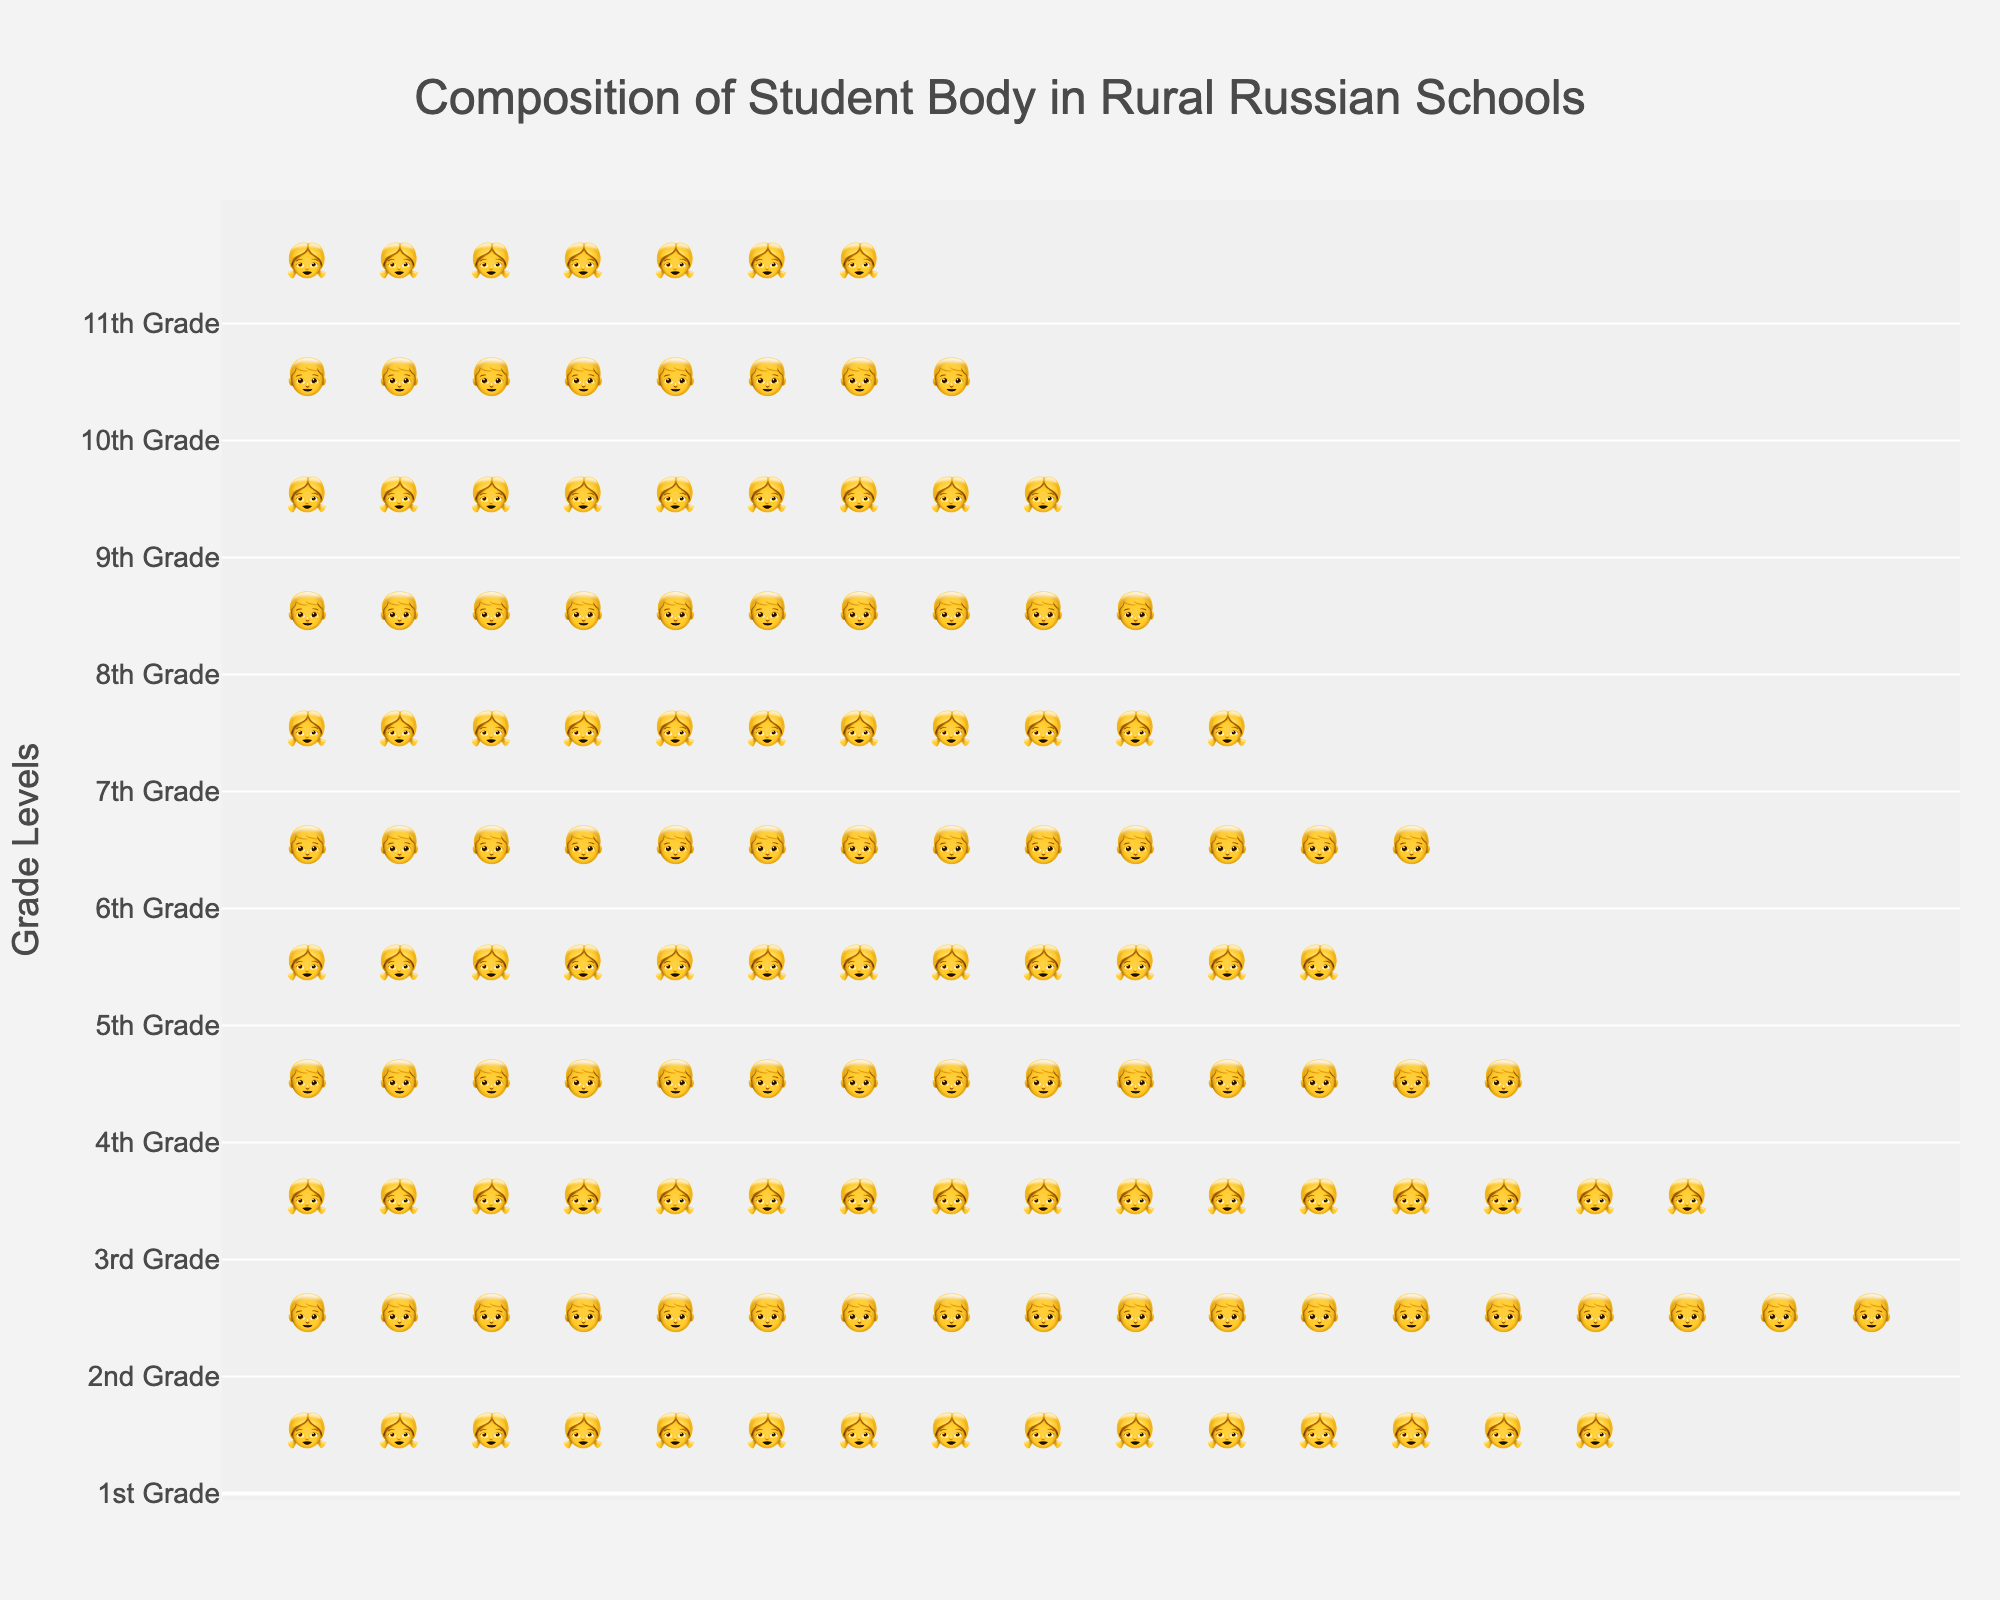what is the title of the figure? The title is usually placed at the top of the figure. It provides a brief description of what the figure illustrates. Here, it is written in a large font to be easily visible.
Answer: Composition of Student Body in Rural Russian Schools How many students are in 2nd grade? The figure uses icons to represent students. There are 18 icons for the 2nd grade, indicating the number of students.
Answer: 18 Which grade has the least number of students? By comparing the number of icons for each grade, 11th grade has the fewest, with only 7 icons.
Answer: 11th Grade What is the difference in the number of students between 1st and 11th grades? Grade 1 has 15 students, and grade 11 has 7. The difference is calculated by subtracting 7 from 15.
Answer: 8 Which grades have more boys than girls? Icons represent boys and girls. By counting the icons per grade, 2nd, 4th, 6th, 8th, 10th grades have more boys (represented by 👦) than girls.
Answer: 2nd, 4th, 6th, 8th, and 10th Grades What is the total number of students from the 5th to 8th grades? Sum the number of students in 5th, 6th, 7th, and 8th grades: 12 (5th) + 13 (6th) + 11 (7th) + 10 (8th).
Answer: 46 Which grade has the largest number of students? By counting and comparing the icons for each grade, 2nd grade has the most, with 18 students.
Answer: 2nd Grade How many more students are in 1st grade compared to 3rd grade? Count the icons for 1st grade (15) and 3rd grade (16). Subtract the smaller value from the larger value: 15 - 16.
Answer: -1 What is the average number of students per grade if the total number of grades is 11? Sum the number of students in all grades and divide by the total number of grades. (15+18+16+14+12+13+11+10+9+8+7) / 11.
Answer: 12.64 